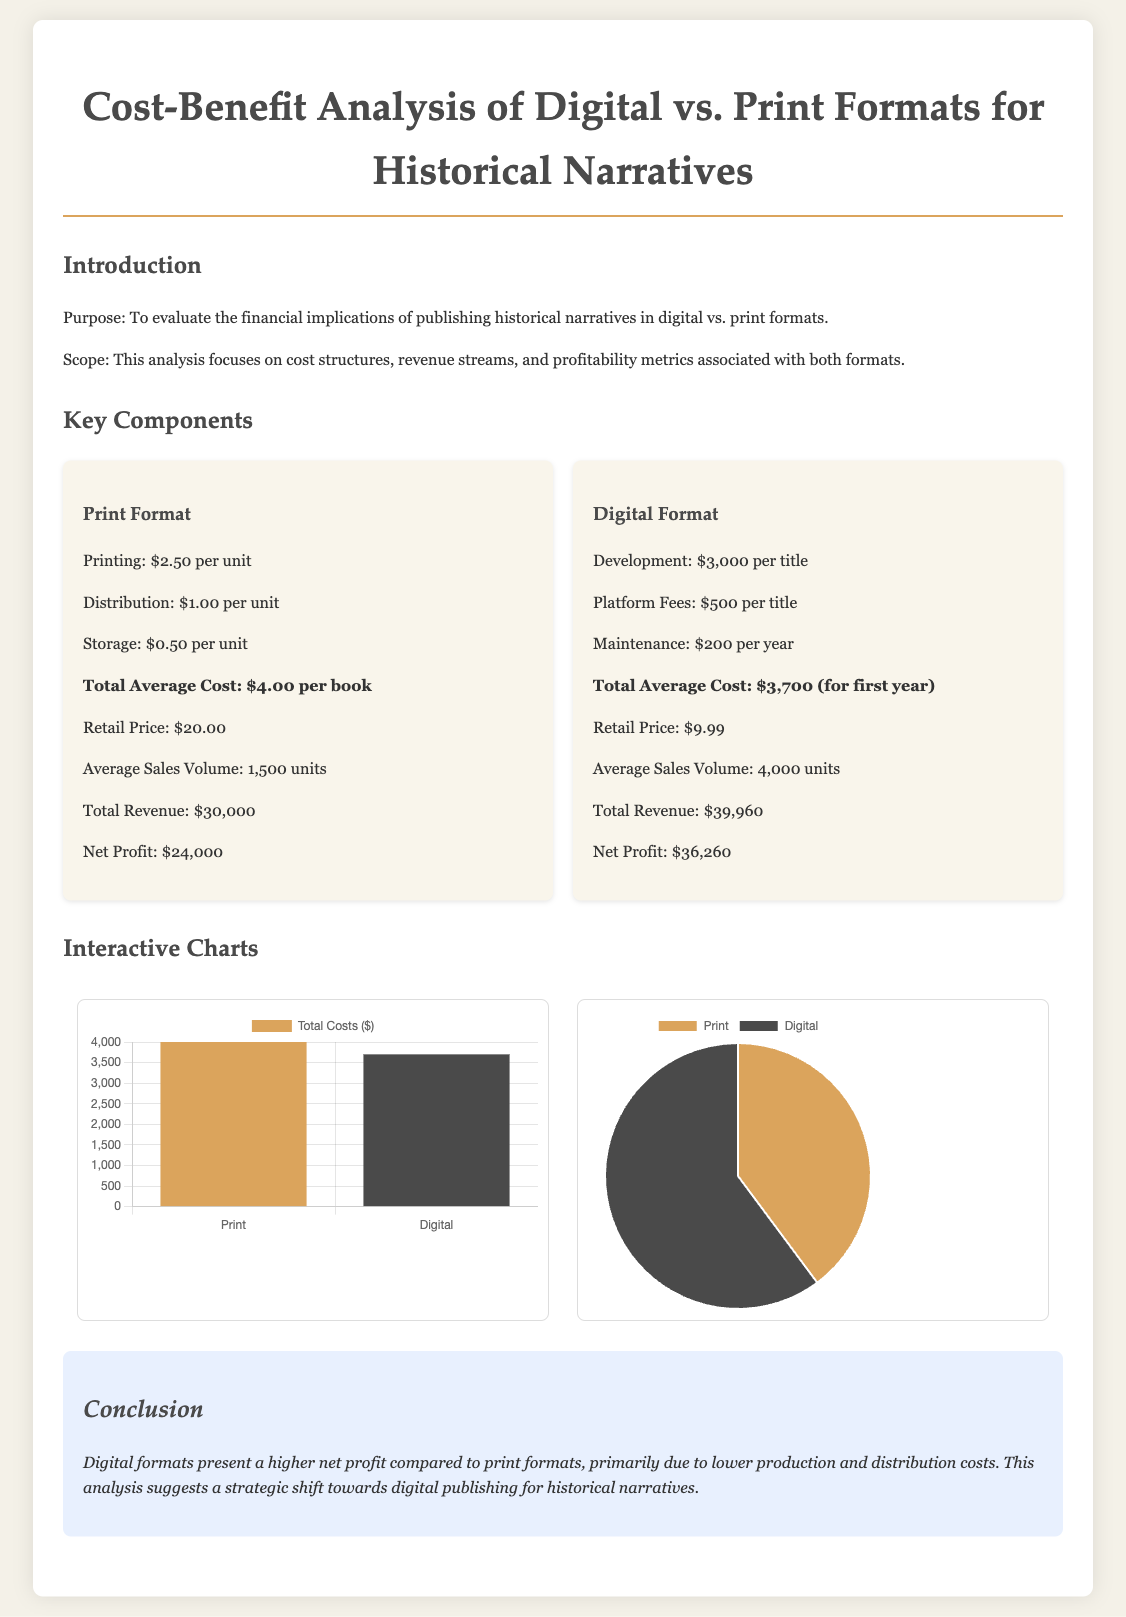What is the total average cost for print format? The total average cost for print format is mentioned in the document as $4.00 per book.
Answer: $4.00 What is the average sales volume for digital format? The average sales volume for digital format is provided in the document, which is 4,000 units.
Answer: 4,000 units What is the retail price of a print book? The retail price of a print book is stated in the document as $20.00.
Answer: $20.00 What is the net profit for digital format? The net profit for digital format is listed as $36,260 in the document.
Answer: $36,260 Which format has a higher total revenue? The total revenue for the formats is compared in the document; digital format has a higher revenue at $39,960 compared to print's $30,000.
Answer: Digital format What is the cost of maintenance for the digital format? The cost of maintenance for the digital format is mentioned in the document as $200 per year.
Answer: $200 per year What do the charts in the document represent? The charts represent a visual comparison of total costs and profit distribution between print and digital formats in the report.
Answer: Comparison of total costs and profit distribution How does the document recommend shifting publishing formats? The document suggests a strategic shift towards digital publishing for historical narratives based on profitability analysis.
Answer: Strategic shift towards digital publishing 